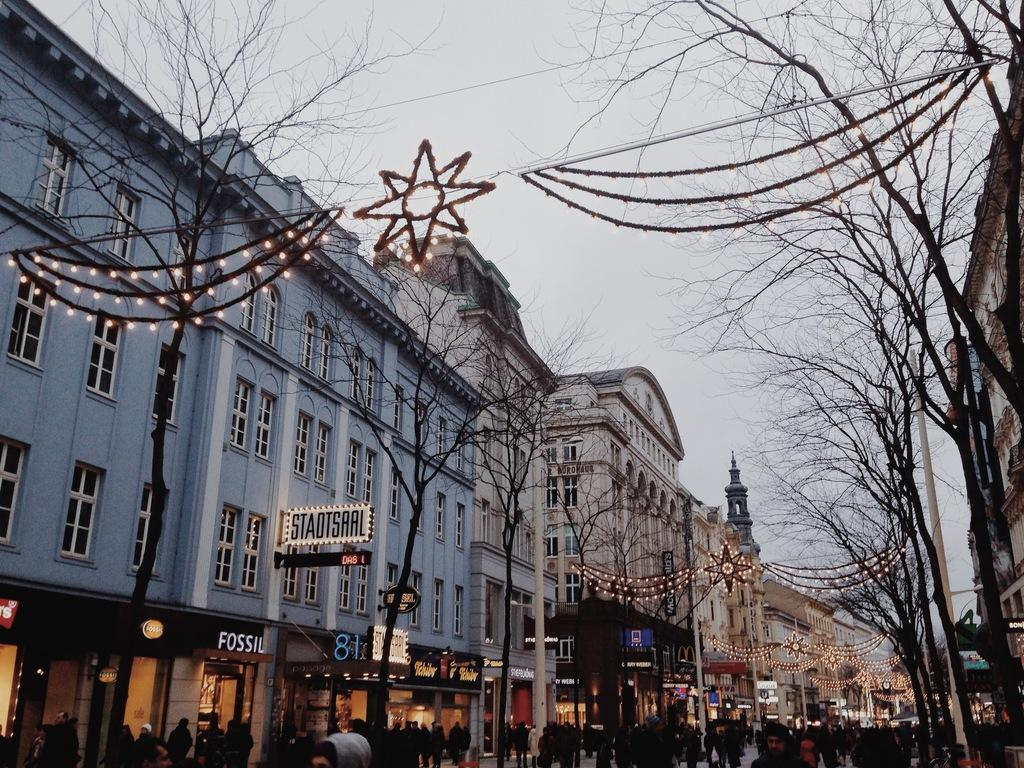What type of structures can be seen in the image? There are buildings in the image. What other natural elements are present in the image? There are trees in the image. Are there any living beings visible in the image? Yes, there are people visible in the image. What is visible at the top of the image? The sky is visible at the top of the image. What type of fuel is being used by the prison in the image? There is no prison present in the image, and therefore no fuel usage can be observed. How does the help system work for the people in the image? There is no mention of a help system in the image, so it cannot be determined how it works. 